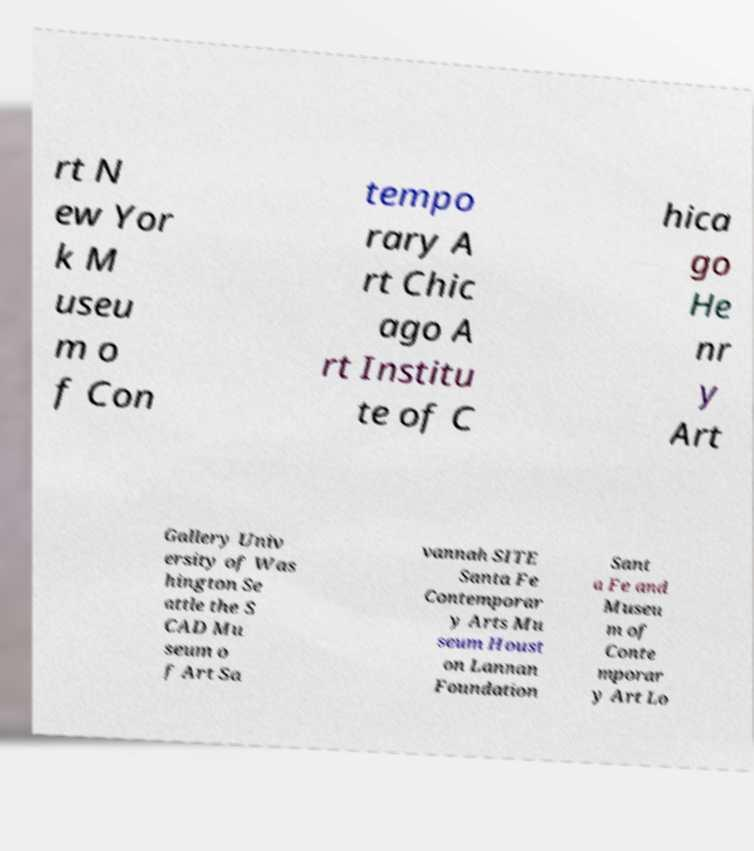Please read and relay the text visible in this image. What does it say? rt N ew Yor k M useu m o f Con tempo rary A rt Chic ago A rt Institu te of C hica go He nr y Art Gallery Univ ersity of Was hington Se attle the S CAD Mu seum o f Art Sa vannah SITE Santa Fe Contemporar y Arts Mu seum Houst on Lannan Foundation Sant a Fe and Museu m of Conte mporar y Art Lo 